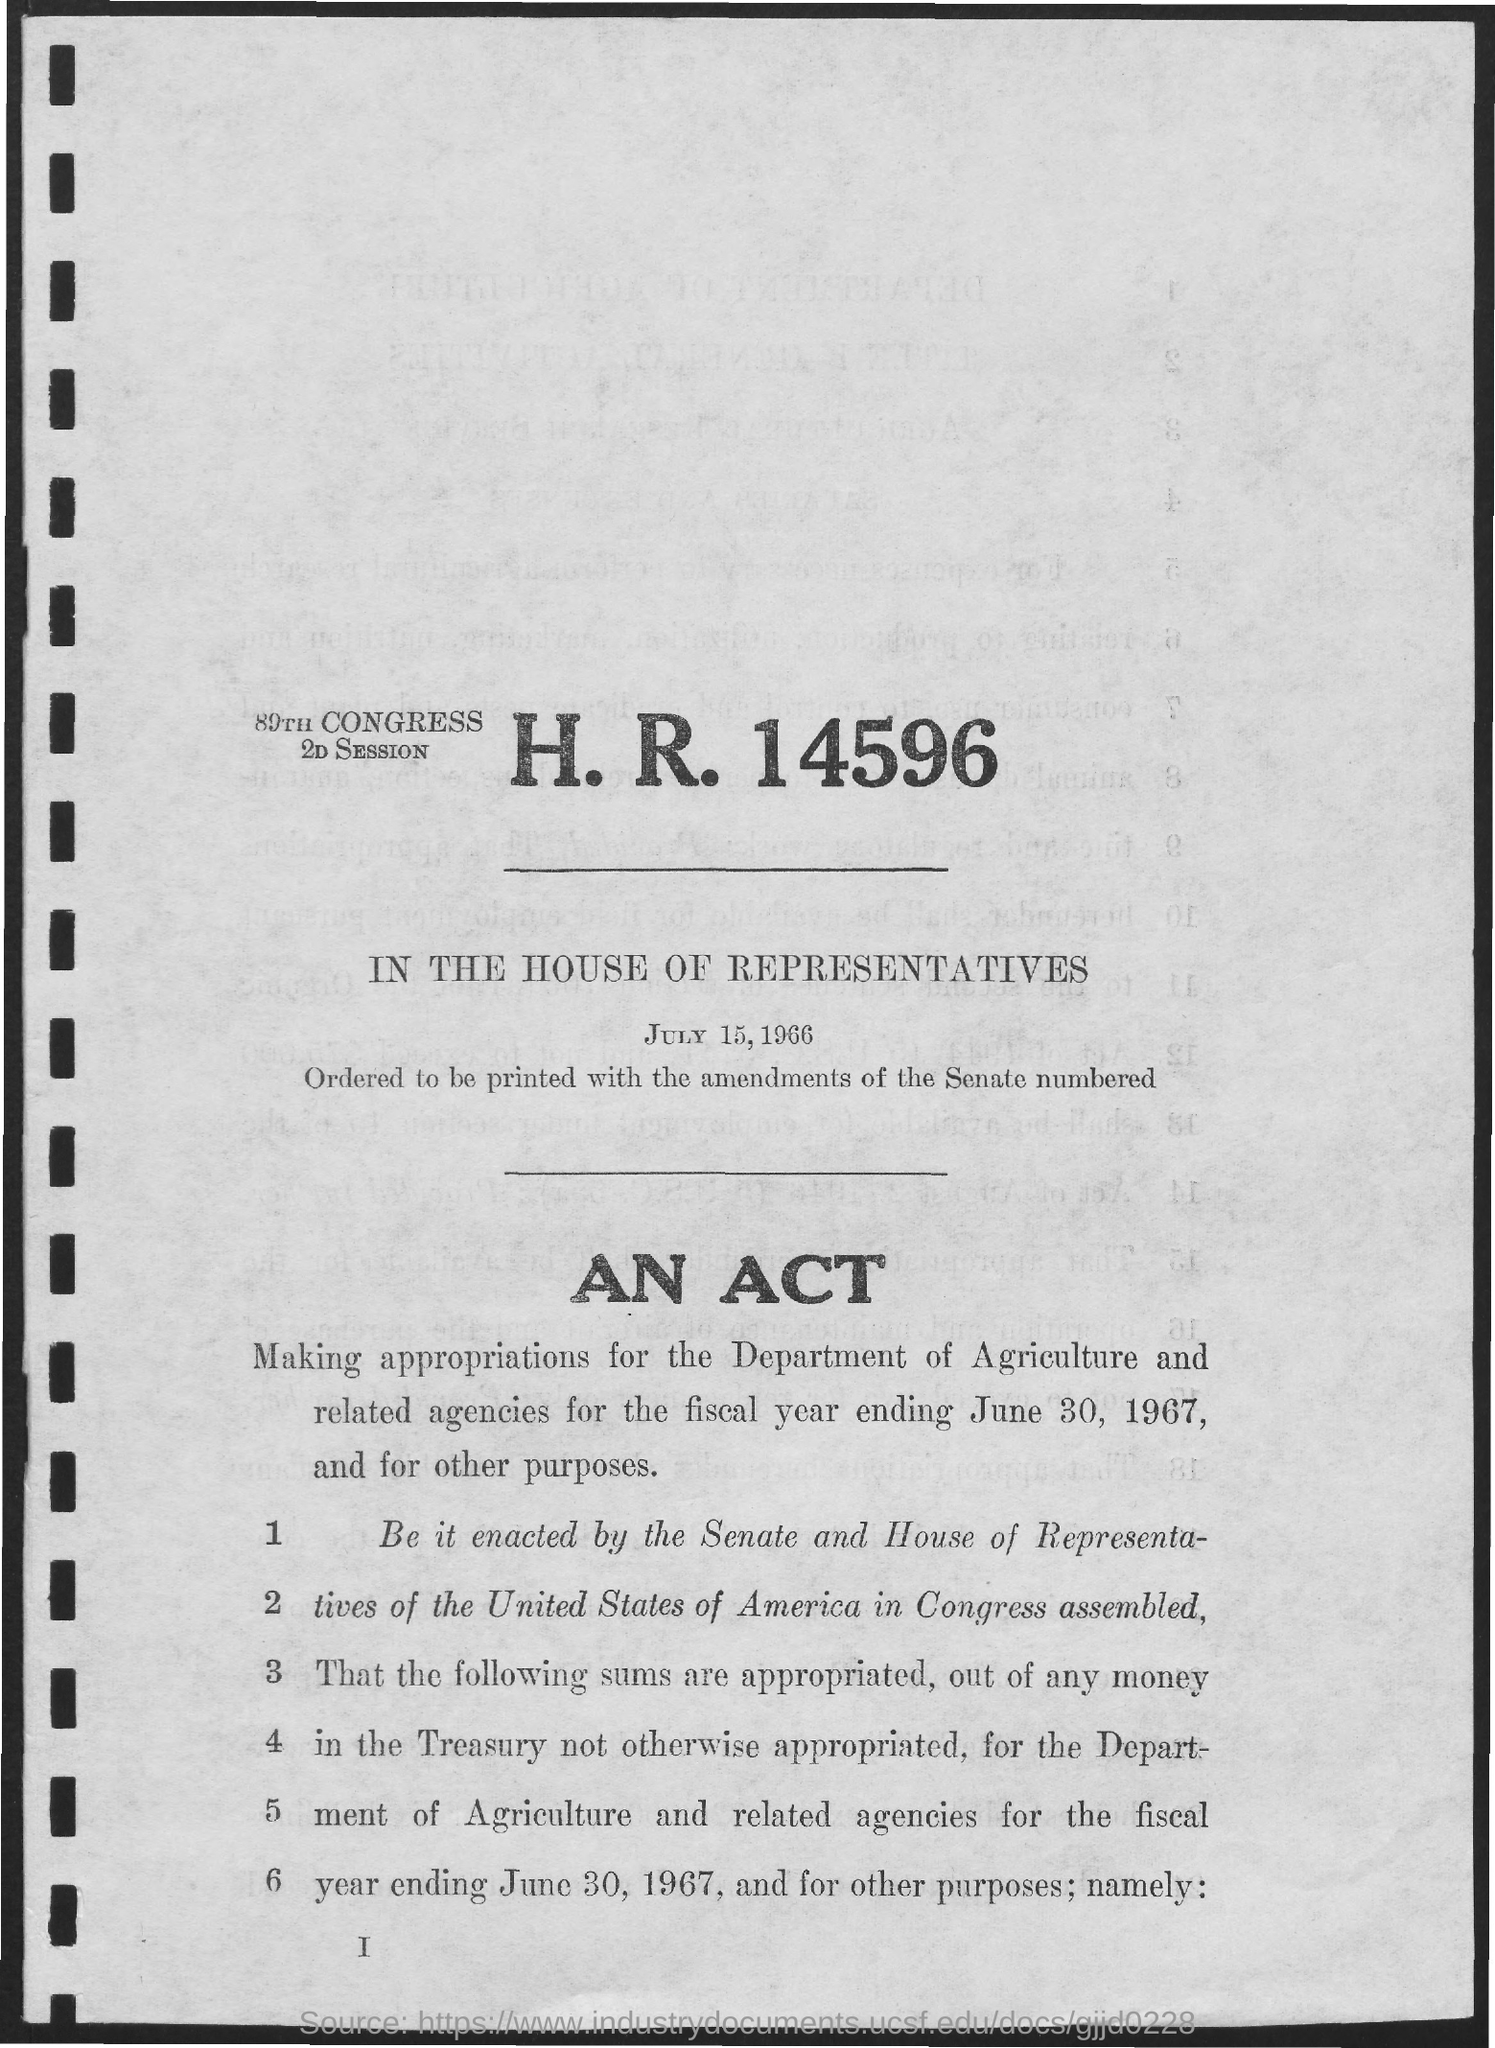List a handful of essential elements in this visual. We, the Senate and House of Representatives of the United States of America, assembled in Congress. 